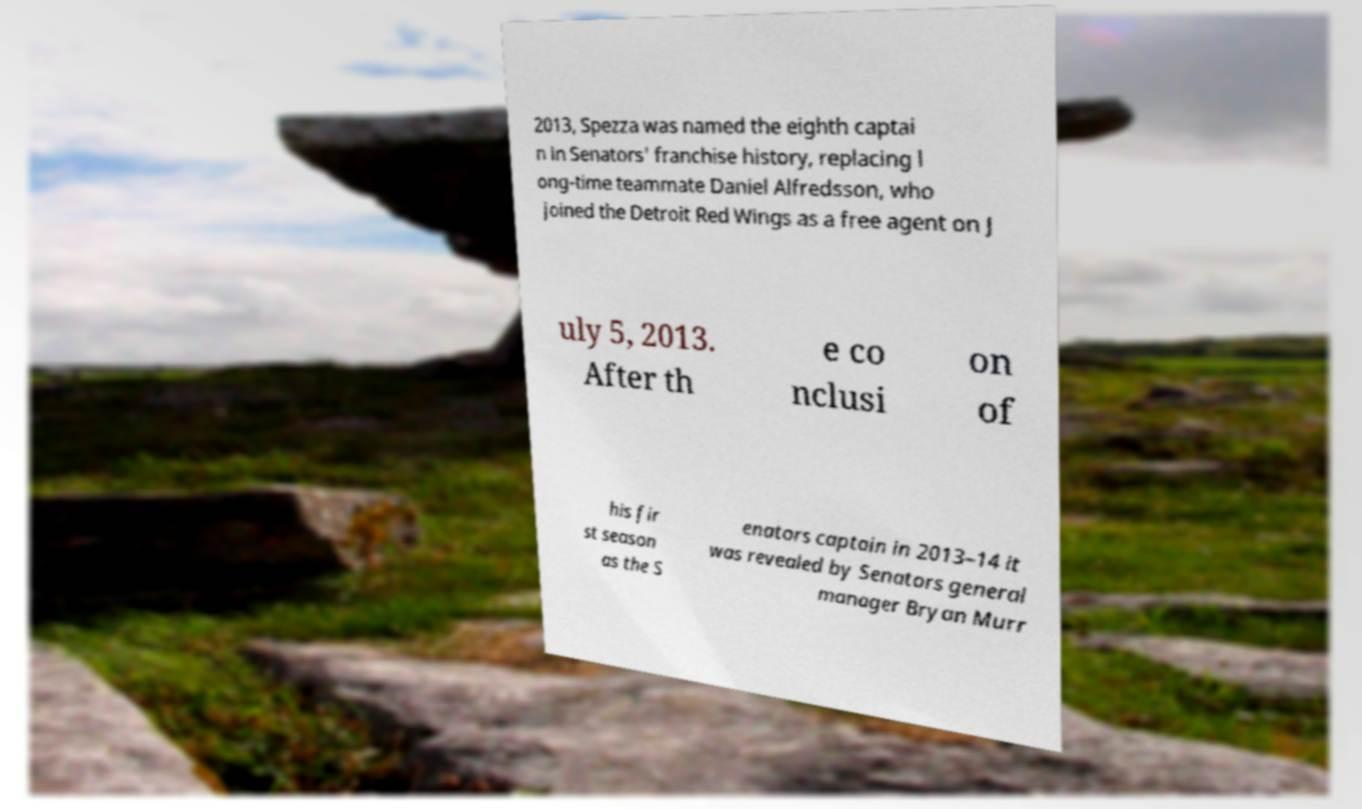Can you read and provide the text displayed in the image?This photo seems to have some interesting text. Can you extract and type it out for me? 2013, Spezza was named the eighth captai n in Senators' franchise history, replacing l ong-time teammate Daniel Alfredsson, who joined the Detroit Red Wings as a free agent on J uly 5, 2013. After th e co nclusi on of his fir st season as the S enators captain in 2013–14 it was revealed by Senators general manager Bryan Murr 